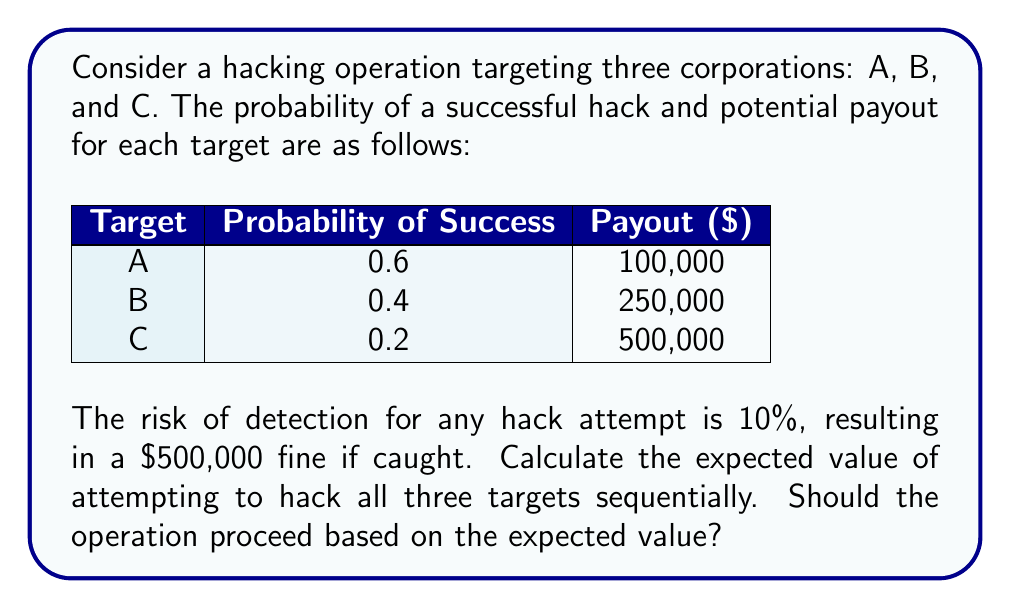Help me with this question. Let's approach this step-by-step:

1) First, calculate the expected value (EV) for each target:

   Target A: $EV_A = 0.6 \times \$100,000 = \$60,000$
   Target B: $EV_B = 0.4 \times \$250,000 = \$100,000$
   Target C: $EV_C = 0.2 \times \$500,000 = \$100,000$

2) The total expected payout is the sum of these:

   $EV_{payout} = \$60,000 + \$100,000 + \$100,000 = \$260,000$

3) Now, calculate the expected cost due to the risk of detection:
   
   Probability of being detected at least once = $1 - (0.9)^3 = 0.271$ (as 0.9 is the probability of not being detected for each attempt)

   Expected cost = $0.271 \times \$500,000 = \$135,500$

4) The total expected value is the difference between the expected payout and the expected cost:

   $EV_{total} = \$260,000 - \$135,500 = \$124,500$

5) Since the expected value is positive, the operation should proceed based on this calculation.
Answer: $\$124,500; Yes, proceed 